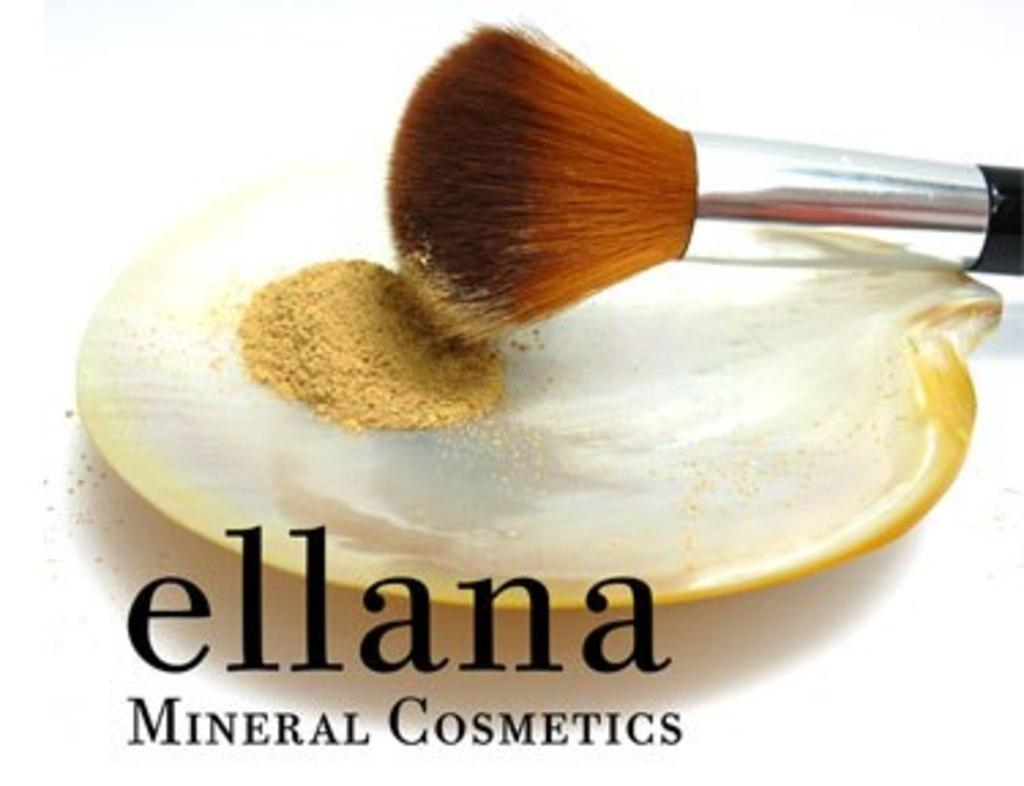<image>
Render a clear and concise summary of the photo. a makeup brush on a tray with powder that is from ellana mineral cosmetics 